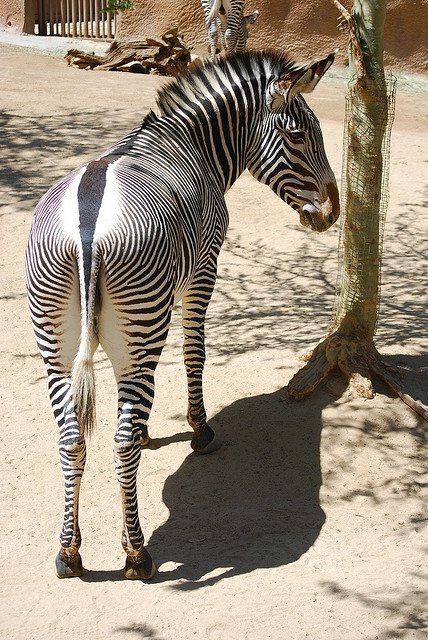Describe the objects in this image and their specific colors. I can see zebra in tan, black, white, gray, and darkgray tones and zebra in tan, black, gray, and maroon tones in this image. 